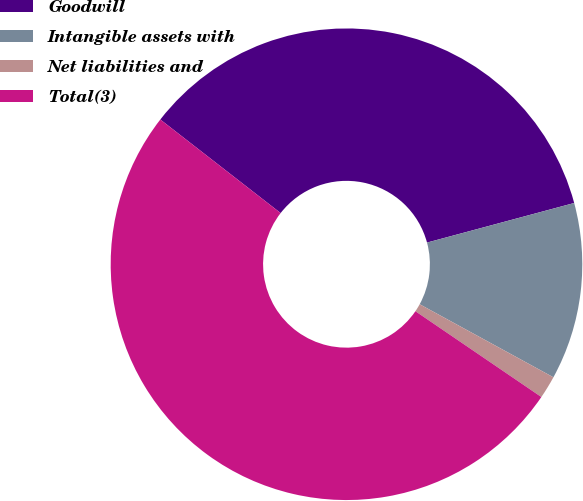Convert chart. <chart><loc_0><loc_0><loc_500><loc_500><pie_chart><fcel>Goodwill<fcel>Intangible assets with<fcel>Net liabilities and<fcel>Total(3)<nl><fcel>35.3%<fcel>12.14%<fcel>1.56%<fcel>51.0%<nl></chart> 